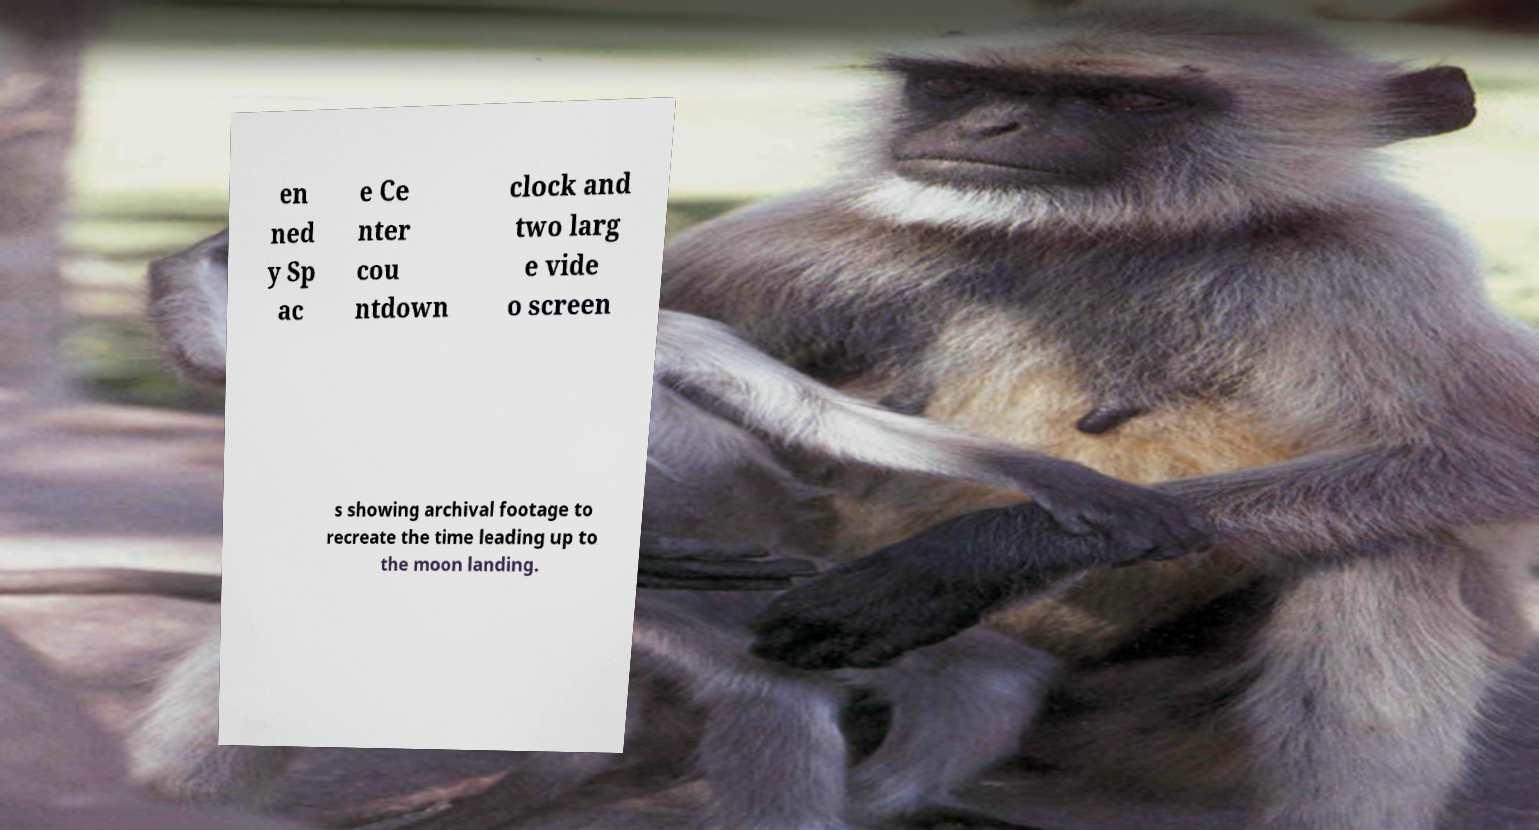Could you assist in decoding the text presented in this image and type it out clearly? en ned y Sp ac e Ce nter cou ntdown clock and two larg e vide o screen s showing archival footage to recreate the time leading up to the moon landing. 